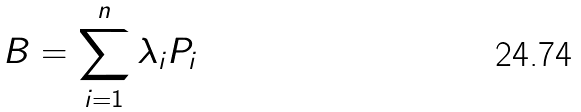Convert formula to latex. <formula><loc_0><loc_0><loc_500><loc_500>B = \sum _ { i = 1 } ^ { n } \lambda _ { i } P _ { i }</formula> 